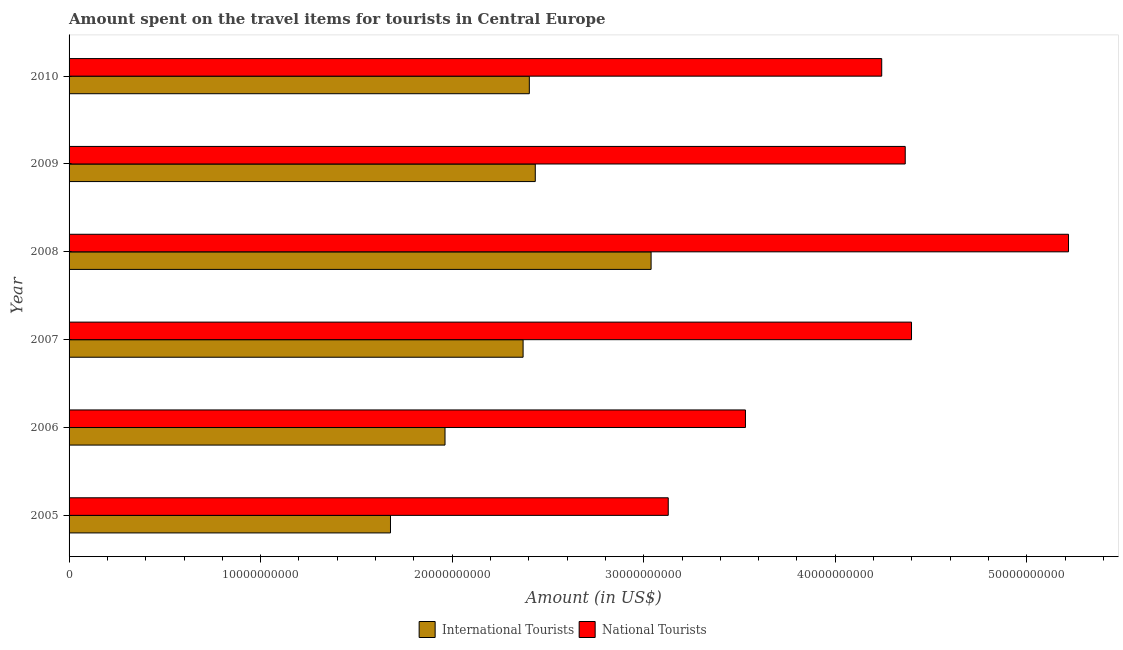How many bars are there on the 4th tick from the bottom?
Your answer should be compact. 2. What is the amount spent on travel items of national tourists in 2006?
Offer a terse response. 3.53e+1. Across all years, what is the maximum amount spent on travel items of national tourists?
Offer a very short reply. 5.22e+1. Across all years, what is the minimum amount spent on travel items of international tourists?
Your answer should be very brief. 1.68e+1. What is the total amount spent on travel items of international tourists in the graph?
Keep it short and to the point. 1.39e+11. What is the difference between the amount spent on travel items of international tourists in 2007 and that in 2008?
Ensure brevity in your answer.  -6.68e+09. What is the difference between the amount spent on travel items of international tourists in 2006 and the amount spent on travel items of national tourists in 2007?
Make the answer very short. -2.44e+1. What is the average amount spent on travel items of national tourists per year?
Offer a terse response. 4.15e+1. In the year 2008, what is the difference between the amount spent on travel items of international tourists and amount spent on travel items of national tourists?
Ensure brevity in your answer.  -2.18e+1. In how many years, is the amount spent on travel items of national tourists greater than 46000000000 US$?
Provide a short and direct response. 1. What is the ratio of the amount spent on travel items of international tourists in 2006 to that in 2007?
Ensure brevity in your answer.  0.83. What is the difference between the highest and the second highest amount spent on travel items of international tourists?
Give a very brief answer. 6.05e+09. What is the difference between the highest and the lowest amount spent on travel items of international tourists?
Keep it short and to the point. 1.36e+1. In how many years, is the amount spent on travel items of international tourists greater than the average amount spent on travel items of international tourists taken over all years?
Make the answer very short. 4. Is the sum of the amount spent on travel items of international tourists in 2007 and 2008 greater than the maximum amount spent on travel items of national tourists across all years?
Give a very brief answer. Yes. What does the 1st bar from the top in 2010 represents?
Offer a terse response. National Tourists. What does the 2nd bar from the bottom in 2010 represents?
Offer a terse response. National Tourists. Are the values on the major ticks of X-axis written in scientific E-notation?
Offer a terse response. No. Does the graph contain any zero values?
Make the answer very short. No. Does the graph contain grids?
Your response must be concise. No. What is the title of the graph?
Provide a short and direct response. Amount spent on the travel items for tourists in Central Europe. Does "Borrowers" appear as one of the legend labels in the graph?
Provide a short and direct response. No. What is the label or title of the X-axis?
Your response must be concise. Amount (in US$). What is the Amount (in US$) in International Tourists in 2005?
Ensure brevity in your answer.  1.68e+1. What is the Amount (in US$) in National Tourists in 2005?
Your response must be concise. 3.13e+1. What is the Amount (in US$) of International Tourists in 2006?
Ensure brevity in your answer.  1.96e+1. What is the Amount (in US$) in National Tourists in 2006?
Provide a succinct answer. 3.53e+1. What is the Amount (in US$) in International Tourists in 2007?
Offer a very short reply. 2.37e+1. What is the Amount (in US$) of National Tourists in 2007?
Provide a short and direct response. 4.40e+1. What is the Amount (in US$) in International Tourists in 2008?
Provide a succinct answer. 3.04e+1. What is the Amount (in US$) in National Tourists in 2008?
Give a very brief answer. 5.22e+1. What is the Amount (in US$) of International Tourists in 2009?
Your answer should be compact. 2.43e+1. What is the Amount (in US$) of National Tourists in 2009?
Keep it short and to the point. 4.37e+1. What is the Amount (in US$) of International Tourists in 2010?
Make the answer very short. 2.40e+1. What is the Amount (in US$) in National Tourists in 2010?
Offer a terse response. 4.24e+1. Across all years, what is the maximum Amount (in US$) in International Tourists?
Your answer should be compact. 3.04e+1. Across all years, what is the maximum Amount (in US$) of National Tourists?
Offer a terse response. 5.22e+1. Across all years, what is the minimum Amount (in US$) in International Tourists?
Provide a short and direct response. 1.68e+1. Across all years, what is the minimum Amount (in US$) of National Tourists?
Your answer should be very brief. 3.13e+1. What is the total Amount (in US$) in International Tourists in the graph?
Keep it short and to the point. 1.39e+11. What is the total Amount (in US$) in National Tourists in the graph?
Provide a short and direct response. 2.49e+11. What is the difference between the Amount (in US$) in International Tourists in 2005 and that in 2006?
Your response must be concise. -2.85e+09. What is the difference between the Amount (in US$) of National Tourists in 2005 and that in 2006?
Offer a terse response. -4.03e+09. What is the difference between the Amount (in US$) of International Tourists in 2005 and that in 2007?
Your response must be concise. -6.92e+09. What is the difference between the Amount (in US$) of National Tourists in 2005 and that in 2007?
Make the answer very short. -1.27e+1. What is the difference between the Amount (in US$) of International Tourists in 2005 and that in 2008?
Ensure brevity in your answer.  -1.36e+1. What is the difference between the Amount (in US$) of National Tourists in 2005 and that in 2008?
Provide a short and direct response. -2.09e+1. What is the difference between the Amount (in US$) of International Tourists in 2005 and that in 2009?
Your answer should be compact. -7.56e+09. What is the difference between the Amount (in US$) in National Tourists in 2005 and that in 2009?
Offer a very short reply. -1.24e+1. What is the difference between the Amount (in US$) of International Tourists in 2005 and that in 2010?
Offer a terse response. -7.25e+09. What is the difference between the Amount (in US$) of National Tourists in 2005 and that in 2010?
Ensure brevity in your answer.  -1.11e+1. What is the difference between the Amount (in US$) of International Tourists in 2006 and that in 2007?
Keep it short and to the point. -4.08e+09. What is the difference between the Amount (in US$) of National Tourists in 2006 and that in 2007?
Provide a short and direct response. -8.67e+09. What is the difference between the Amount (in US$) of International Tourists in 2006 and that in 2008?
Ensure brevity in your answer.  -1.08e+1. What is the difference between the Amount (in US$) of National Tourists in 2006 and that in 2008?
Make the answer very short. -1.69e+1. What is the difference between the Amount (in US$) of International Tourists in 2006 and that in 2009?
Give a very brief answer. -4.71e+09. What is the difference between the Amount (in US$) in National Tourists in 2006 and that in 2009?
Give a very brief answer. -8.34e+09. What is the difference between the Amount (in US$) in International Tourists in 2006 and that in 2010?
Your answer should be very brief. -4.40e+09. What is the difference between the Amount (in US$) in National Tourists in 2006 and that in 2010?
Ensure brevity in your answer.  -7.11e+09. What is the difference between the Amount (in US$) in International Tourists in 2007 and that in 2008?
Keep it short and to the point. -6.68e+09. What is the difference between the Amount (in US$) of National Tourists in 2007 and that in 2008?
Offer a very short reply. -8.20e+09. What is the difference between the Amount (in US$) of International Tourists in 2007 and that in 2009?
Give a very brief answer. -6.36e+08. What is the difference between the Amount (in US$) in National Tourists in 2007 and that in 2009?
Provide a short and direct response. 3.28e+08. What is the difference between the Amount (in US$) in International Tourists in 2007 and that in 2010?
Your answer should be very brief. -3.25e+08. What is the difference between the Amount (in US$) in National Tourists in 2007 and that in 2010?
Make the answer very short. 1.56e+09. What is the difference between the Amount (in US$) in International Tourists in 2008 and that in 2009?
Keep it short and to the point. 6.05e+09. What is the difference between the Amount (in US$) of National Tourists in 2008 and that in 2009?
Your answer should be compact. 8.52e+09. What is the difference between the Amount (in US$) in International Tourists in 2008 and that in 2010?
Offer a terse response. 6.36e+09. What is the difference between the Amount (in US$) in National Tourists in 2008 and that in 2010?
Give a very brief answer. 9.75e+09. What is the difference between the Amount (in US$) in International Tourists in 2009 and that in 2010?
Give a very brief answer. 3.11e+08. What is the difference between the Amount (in US$) of National Tourists in 2009 and that in 2010?
Give a very brief answer. 1.23e+09. What is the difference between the Amount (in US$) in International Tourists in 2005 and the Amount (in US$) in National Tourists in 2006?
Offer a terse response. -1.85e+1. What is the difference between the Amount (in US$) of International Tourists in 2005 and the Amount (in US$) of National Tourists in 2007?
Offer a very short reply. -2.72e+1. What is the difference between the Amount (in US$) of International Tourists in 2005 and the Amount (in US$) of National Tourists in 2008?
Your answer should be compact. -3.54e+1. What is the difference between the Amount (in US$) of International Tourists in 2005 and the Amount (in US$) of National Tourists in 2009?
Offer a very short reply. -2.69e+1. What is the difference between the Amount (in US$) of International Tourists in 2005 and the Amount (in US$) of National Tourists in 2010?
Make the answer very short. -2.56e+1. What is the difference between the Amount (in US$) of International Tourists in 2006 and the Amount (in US$) of National Tourists in 2007?
Offer a very short reply. -2.44e+1. What is the difference between the Amount (in US$) in International Tourists in 2006 and the Amount (in US$) in National Tourists in 2008?
Your response must be concise. -3.25e+1. What is the difference between the Amount (in US$) in International Tourists in 2006 and the Amount (in US$) in National Tourists in 2009?
Provide a succinct answer. -2.40e+1. What is the difference between the Amount (in US$) of International Tourists in 2006 and the Amount (in US$) of National Tourists in 2010?
Ensure brevity in your answer.  -2.28e+1. What is the difference between the Amount (in US$) in International Tourists in 2007 and the Amount (in US$) in National Tourists in 2008?
Your response must be concise. -2.85e+1. What is the difference between the Amount (in US$) in International Tourists in 2007 and the Amount (in US$) in National Tourists in 2009?
Your answer should be very brief. -1.99e+1. What is the difference between the Amount (in US$) of International Tourists in 2007 and the Amount (in US$) of National Tourists in 2010?
Keep it short and to the point. -1.87e+1. What is the difference between the Amount (in US$) in International Tourists in 2008 and the Amount (in US$) in National Tourists in 2009?
Offer a very short reply. -1.33e+1. What is the difference between the Amount (in US$) in International Tourists in 2008 and the Amount (in US$) in National Tourists in 2010?
Ensure brevity in your answer.  -1.20e+1. What is the difference between the Amount (in US$) in International Tourists in 2009 and the Amount (in US$) in National Tourists in 2010?
Your response must be concise. -1.81e+1. What is the average Amount (in US$) in International Tourists per year?
Your response must be concise. 2.31e+1. What is the average Amount (in US$) in National Tourists per year?
Offer a very short reply. 4.15e+1. In the year 2005, what is the difference between the Amount (in US$) of International Tourists and Amount (in US$) of National Tourists?
Provide a short and direct response. -1.45e+1. In the year 2006, what is the difference between the Amount (in US$) in International Tourists and Amount (in US$) in National Tourists?
Make the answer very short. -1.57e+1. In the year 2007, what is the difference between the Amount (in US$) of International Tourists and Amount (in US$) of National Tourists?
Make the answer very short. -2.03e+1. In the year 2008, what is the difference between the Amount (in US$) in International Tourists and Amount (in US$) in National Tourists?
Offer a terse response. -2.18e+1. In the year 2009, what is the difference between the Amount (in US$) of International Tourists and Amount (in US$) of National Tourists?
Your answer should be compact. -1.93e+1. In the year 2010, what is the difference between the Amount (in US$) in International Tourists and Amount (in US$) in National Tourists?
Your answer should be compact. -1.84e+1. What is the ratio of the Amount (in US$) in International Tourists in 2005 to that in 2006?
Keep it short and to the point. 0.85. What is the ratio of the Amount (in US$) in National Tourists in 2005 to that in 2006?
Provide a short and direct response. 0.89. What is the ratio of the Amount (in US$) of International Tourists in 2005 to that in 2007?
Offer a very short reply. 0.71. What is the ratio of the Amount (in US$) in National Tourists in 2005 to that in 2007?
Give a very brief answer. 0.71. What is the ratio of the Amount (in US$) of International Tourists in 2005 to that in 2008?
Your response must be concise. 0.55. What is the ratio of the Amount (in US$) in National Tourists in 2005 to that in 2008?
Provide a short and direct response. 0.6. What is the ratio of the Amount (in US$) in International Tourists in 2005 to that in 2009?
Your answer should be compact. 0.69. What is the ratio of the Amount (in US$) of National Tourists in 2005 to that in 2009?
Ensure brevity in your answer.  0.72. What is the ratio of the Amount (in US$) in International Tourists in 2005 to that in 2010?
Ensure brevity in your answer.  0.7. What is the ratio of the Amount (in US$) of National Tourists in 2005 to that in 2010?
Ensure brevity in your answer.  0.74. What is the ratio of the Amount (in US$) in International Tourists in 2006 to that in 2007?
Provide a short and direct response. 0.83. What is the ratio of the Amount (in US$) in National Tourists in 2006 to that in 2007?
Your answer should be very brief. 0.8. What is the ratio of the Amount (in US$) in International Tourists in 2006 to that in 2008?
Keep it short and to the point. 0.65. What is the ratio of the Amount (in US$) of National Tourists in 2006 to that in 2008?
Provide a succinct answer. 0.68. What is the ratio of the Amount (in US$) in International Tourists in 2006 to that in 2009?
Keep it short and to the point. 0.81. What is the ratio of the Amount (in US$) in National Tourists in 2006 to that in 2009?
Ensure brevity in your answer.  0.81. What is the ratio of the Amount (in US$) of International Tourists in 2006 to that in 2010?
Your answer should be compact. 0.82. What is the ratio of the Amount (in US$) of National Tourists in 2006 to that in 2010?
Your answer should be very brief. 0.83. What is the ratio of the Amount (in US$) in International Tourists in 2007 to that in 2008?
Your answer should be very brief. 0.78. What is the ratio of the Amount (in US$) of National Tourists in 2007 to that in 2008?
Keep it short and to the point. 0.84. What is the ratio of the Amount (in US$) of International Tourists in 2007 to that in 2009?
Make the answer very short. 0.97. What is the ratio of the Amount (in US$) in National Tourists in 2007 to that in 2009?
Your answer should be very brief. 1.01. What is the ratio of the Amount (in US$) in International Tourists in 2007 to that in 2010?
Your answer should be compact. 0.99. What is the ratio of the Amount (in US$) of National Tourists in 2007 to that in 2010?
Provide a short and direct response. 1.04. What is the ratio of the Amount (in US$) in International Tourists in 2008 to that in 2009?
Keep it short and to the point. 1.25. What is the ratio of the Amount (in US$) in National Tourists in 2008 to that in 2009?
Provide a succinct answer. 1.2. What is the ratio of the Amount (in US$) of International Tourists in 2008 to that in 2010?
Offer a very short reply. 1.26. What is the ratio of the Amount (in US$) in National Tourists in 2008 to that in 2010?
Offer a very short reply. 1.23. What is the ratio of the Amount (in US$) in International Tourists in 2009 to that in 2010?
Give a very brief answer. 1.01. What is the ratio of the Amount (in US$) of National Tourists in 2009 to that in 2010?
Provide a succinct answer. 1.03. What is the difference between the highest and the second highest Amount (in US$) of International Tourists?
Keep it short and to the point. 6.05e+09. What is the difference between the highest and the second highest Amount (in US$) in National Tourists?
Your answer should be very brief. 8.20e+09. What is the difference between the highest and the lowest Amount (in US$) of International Tourists?
Provide a succinct answer. 1.36e+1. What is the difference between the highest and the lowest Amount (in US$) of National Tourists?
Provide a short and direct response. 2.09e+1. 